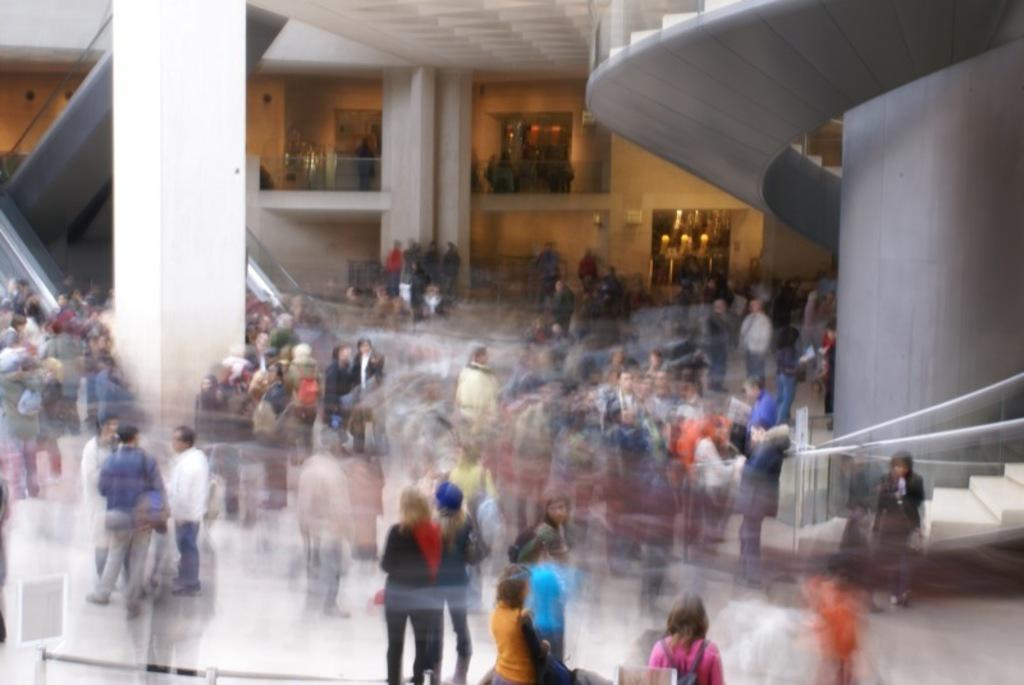What is located in the foreground of the image? There are people in the foreground of the image. What can be seen in the background of the image? There is a building in the background of the image. Where is the staircase located in the image? The staircase is on the right side of the image. What type of transportation is present on the left side of the image? There are escalators on the left side of the image. Can you see any astronauts using a spoon in space in the image? There is no space, astronauts, or spoon present in the image. Is there a rifle visible in the image? There is no rifle present in the image. 